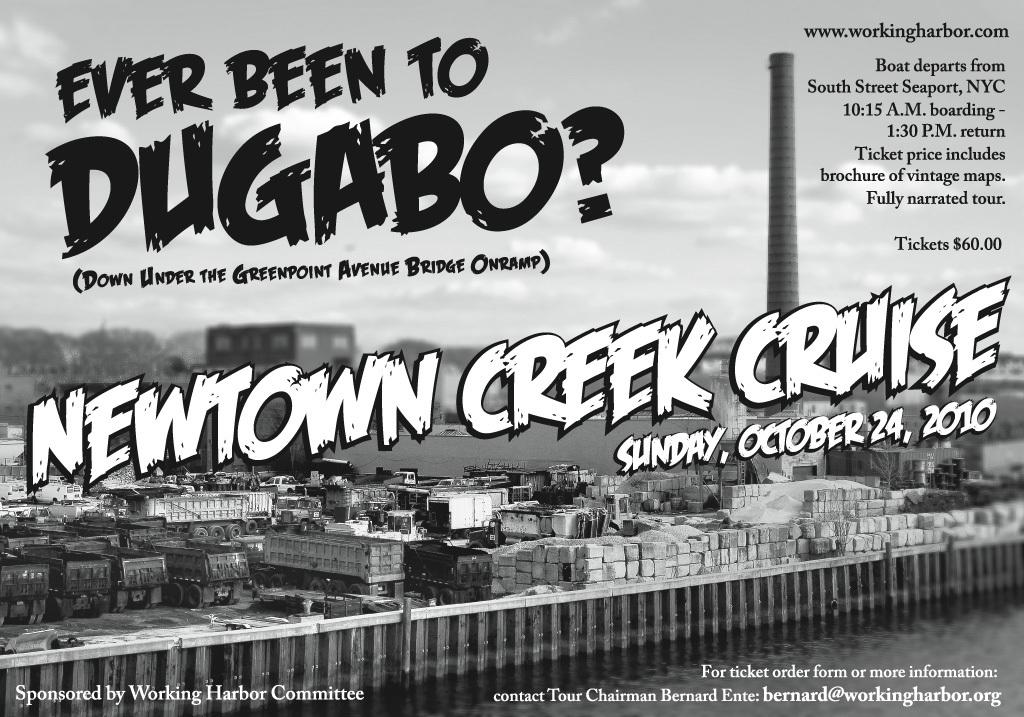<image>
Summarize the visual content of the image. Poster for Newton Creek Cruise that takes place on October 24th. 